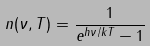<formula> <loc_0><loc_0><loc_500><loc_500>n ( \nu , T ) = \frac { 1 } { e ^ { h \nu / k T } - 1 }</formula> 